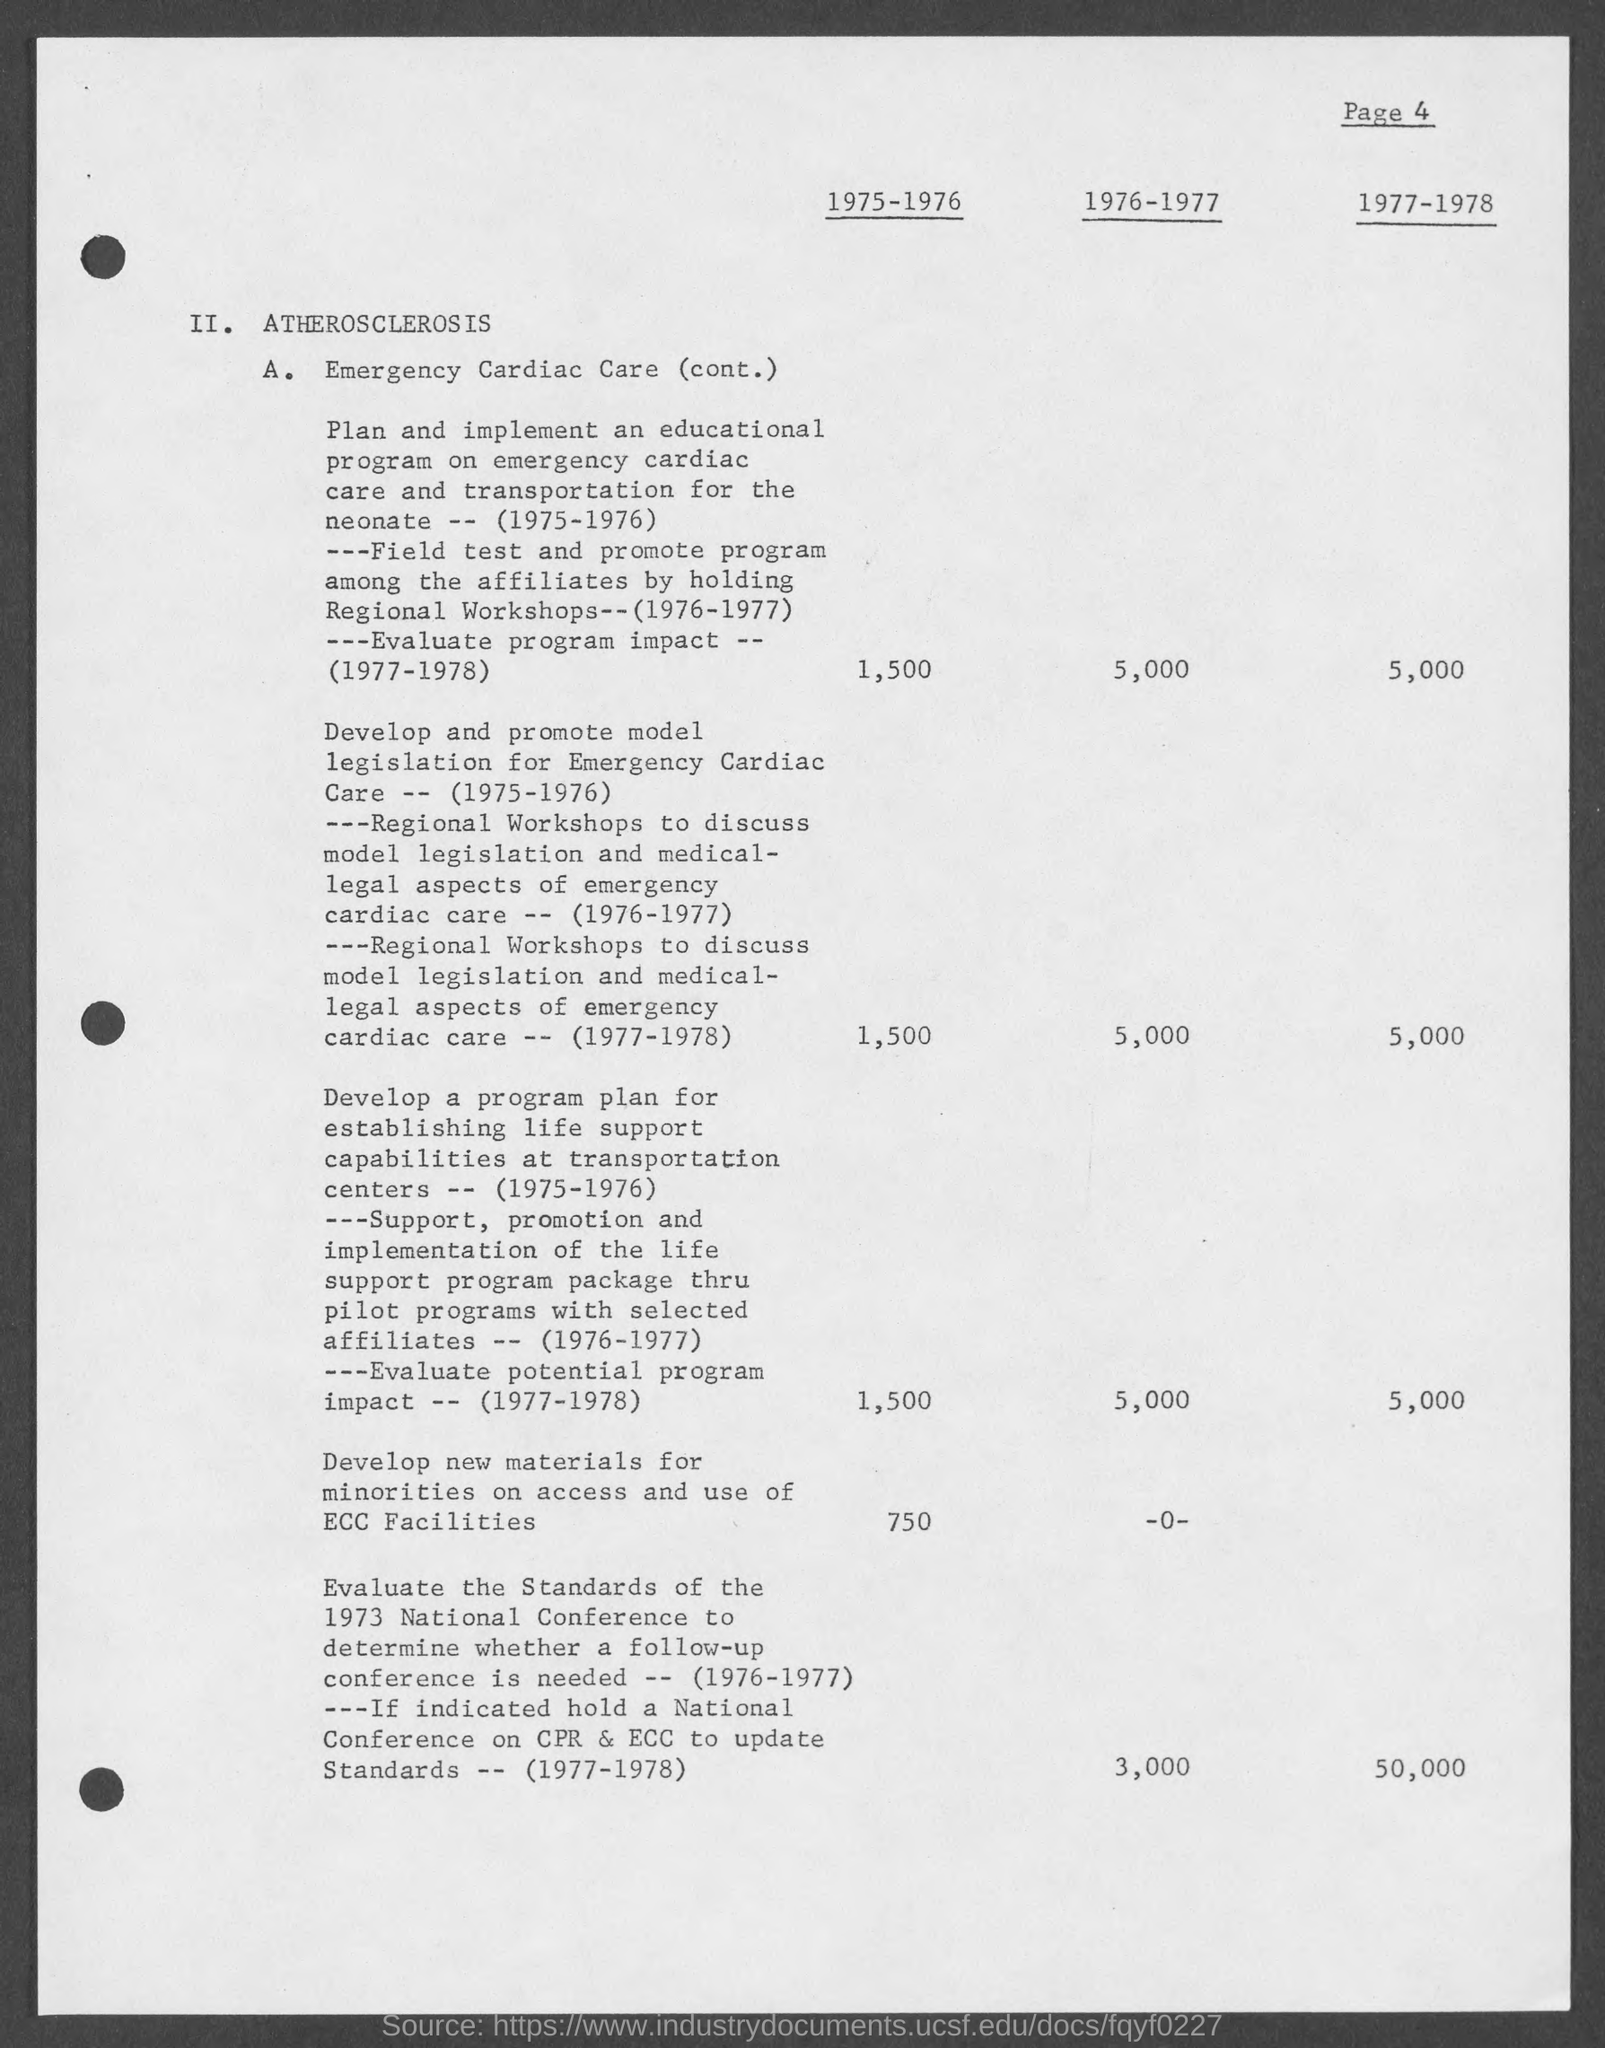Highlight a few significant elements in this photo. The page number at the top of the page is 4. The heading of the document on top is titled "Atherosclerosis. 